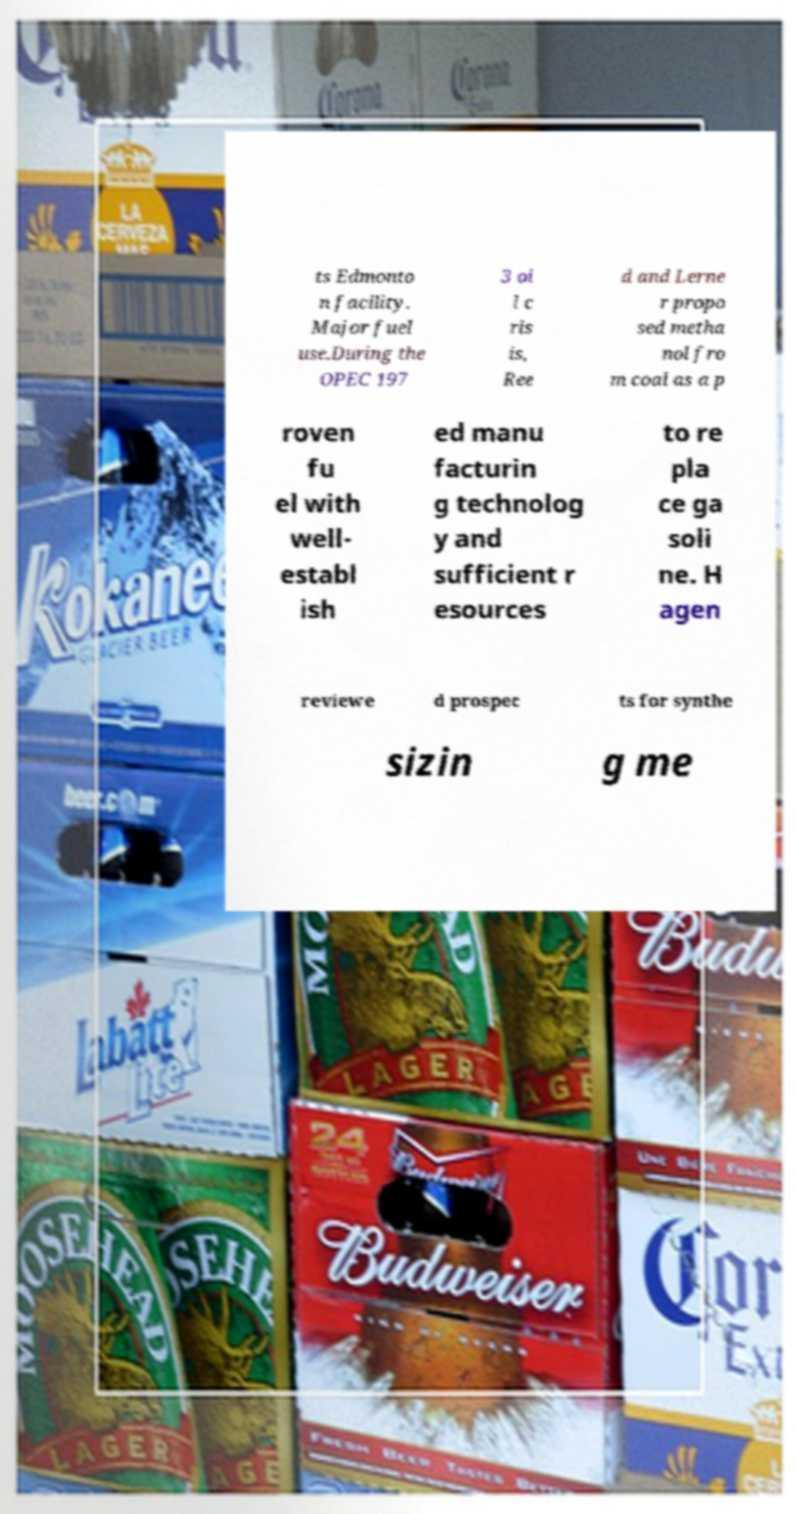For documentation purposes, I need the text within this image transcribed. Could you provide that? ts Edmonto n facility. Major fuel use.During the OPEC 197 3 oi l c ris is, Ree d and Lerne r propo sed metha nol fro m coal as a p roven fu el with well- establ ish ed manu facturin g technolog y and sufficient r esources to re pla ce ga soli ne. H agen reviewe d prospec ts for synthe sizin g me 